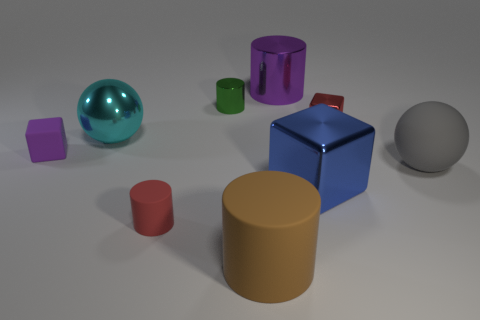How many tiny shiny cubes are the same color as the small rubber cylinder?
Your response must be concise. 1. The thing that is the same color as the small metallic block is what size?
Your answer should be compact. Small. What is the shape of the big blue thing?
Keep it short and to the point. Cube. The other metallic thing that is the same shape as the blue object is what size?
Make the answer very short. Small. Is there anything else that has the same material as the large cyan thing?
Offer a terse response. Yes. What size is the metal cube in front of the purple thing that is to the left of the big metal sphere?
Offer a very short reply. Large. Are there an equal number of shiny cylinders that are right of the blue thing and brown blocks?
Your answer should be very brief. Yes. What number of other things are there of the same color as the rubber ball?
Your answer should be very brief. 0. Is the number of big brown matte things on the left side of the green cylinder less than the number of large green things?
Keep it short and to the point. No. Is there a brown cylinder that has the same size as the purple metal cylinder?
Provide a short and direct response. Yes. 